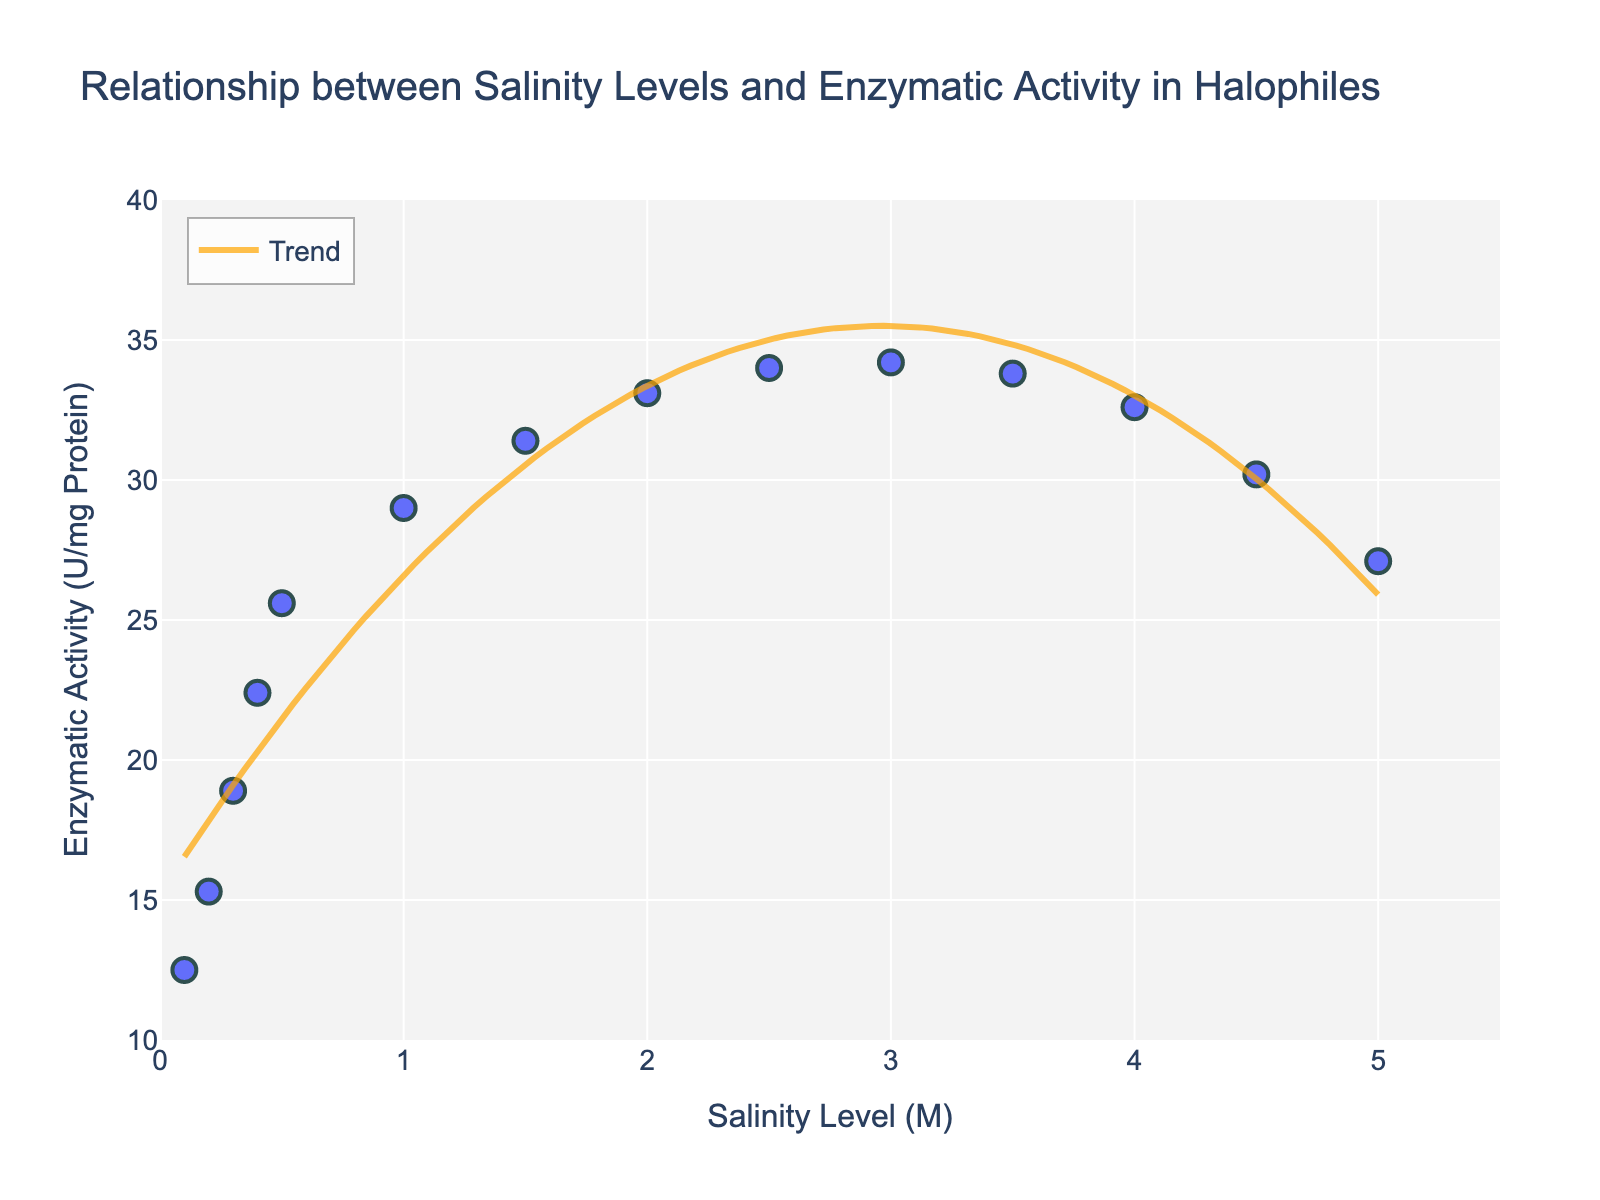How many data points are plotted in the figure? Count the number of individual markers on the plot. There are 14 data points in total as there are 14 individual pairs of salinity levels and enzymatic activity values provided in the dataset.
Answer: 14 What does the trend line indicate about the relationship between salinity levels and enzymatic activity? The trend line is a polynomial (quadratic) fit which appears to rise initially, reaching a peak, and then decline, suggesting an optimal salinity range for maximal enzymatic activity near the middle range and a decrease in activity at both lower and higher salinity levels.
Answer: Optimal range in mid-level salinity What is the highest enzymatic activity recorded, and at what salinity level does it occur? Identify the highest point on the y-axis and note its corresponding x-axis value. The highest enzymatic activity is 34.2 U/mg Protein, which occurs at a salinity level of 3.0 M.
Answer: 34.2 U/mg Protein at 3.0 M What is the general trend in enzymatic activity as salinity levels increase from 0.1 M to 1.0 M? Observe the trend in the data points and trend line as salinity increases from 0.1 M to 1.0 M. The enzymatic activity increases steadily as the salinity level increases from 0.1 M to 1.0 M.
Answer: Increases At what salinity level does the enzymatic activity begin to decline, according to the trend line? Follow the trend line and identify the point after which enzymatic activity starts to decrease. Enzymatic activity begins to decline after a peak around 3.0 M.
Answer: Around 3.0 M How does the enzymatic activity at a salinity level of 2.5 M compare to that at 4.0 M? Compare the y-values for the salinity levels of 2.5 M and 4.0 M. The enzymatic activity at 2.5 M (34.0 U/mg Protein) is higher than at 4.0 M (32.6 U/mg Protein).
Answer: Higher at 2.5 M Based on the trend line, what can be inferred about the enzymatic activity at salinity levels beyond 5.0 M? Extend the logical curve of the trend line and infer the trend. The trend line suggests that enzymatic activity would likely continue to decline beyond 5.0 M.
Answer: Likely to decline What is the range of enzymatic activity values observed in the figure? Identify the minimum and maximum y-values in the data points. The enzymatic activity ranges from 12.5 U/mg Protein to 34.2 U/mg Protein.
Answer: 12.5 to 34.2 U/mg Protein What does the color and style of the trend line signify? Describe the properties of the trend line. The trend line is an orange line with a moderate transparency ('rgba(255, 165, 0, 0.7)'), indicating a quadratic fit to the data.
Answer: Quadratic fit in orange, semi-transparent 